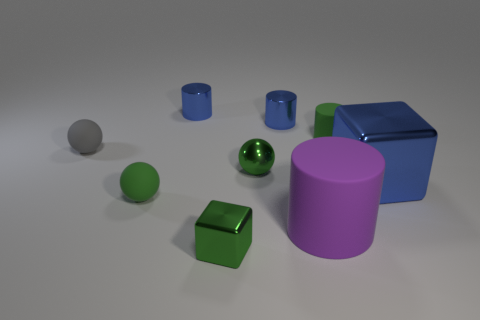What shape is the tiny metal object in front of the cube behind the cylinder that is in front of the tiny green cylinder?
Your response must be concise. Cube. What shape is the gray object that is the same size as the green block?
Make the answer very short. Sphere. How many blue metal cubes are behind the metal cube that is to the right of the small green shiny thing in front of the purple thing?
Offer a terse response. 0. Is the number of green cylinders that are on the left side of the tiny green metal block greater than the number of green shiny balls behind the gray matte thing?
Your answer should be compact. No. How many other metallic objects have the same shape as the gray thing?
Offer a terse response. 1. What number of objects are spheres that are left of the purple rubber cylinder or small blue cylinders that are to the left of the tiny green metal cube?
Offer a very short reply. 4. The thing that is left of the ball in front of the block behind the tiny green metallic cube is made of what material?
Ensure brevity in your answer.  Rubber. Does the big object that is left of the big blue thing have the same color as the small rubber cylinder?
Your response must be concise. No. What is the material of the tiny thing that is in front of the small gray rubber object and right of the green metal block?
Offer a terse response. Metal. Is there a green cylinder that has the same size as the gray matte ball?
Provide a short and direct response. Yes. 